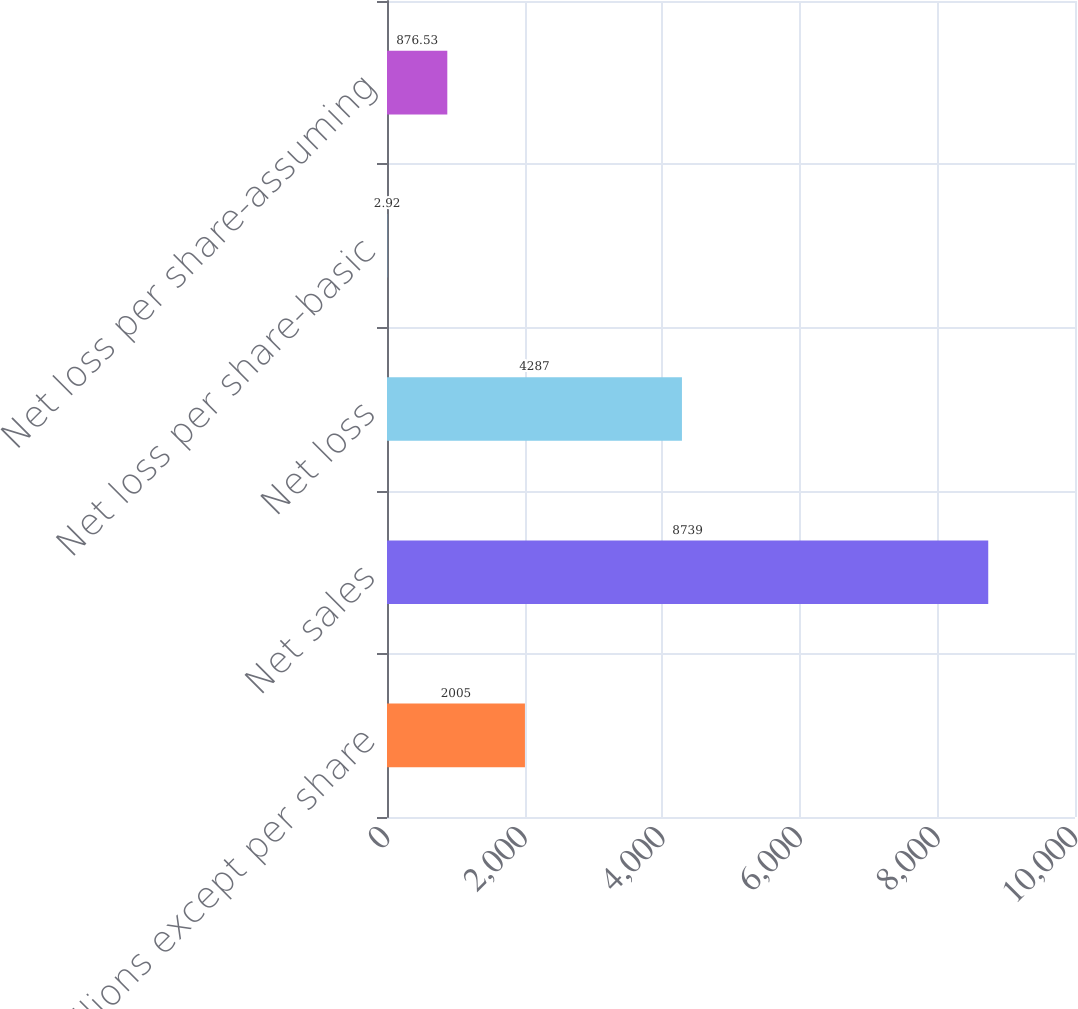<chart> <loc_0><loc_0><loc_500><loc_500><bar_chart><fcel>(in millions except per share<fcel>Net sales<fcel>Net loss<fcel>Net loss per share-basic<fcel>Net loss per share-assuming<nl><fcel>2005<fcel>8739<fcel>4287<fcel>2.92<fcel>876.53<nl></chart> 